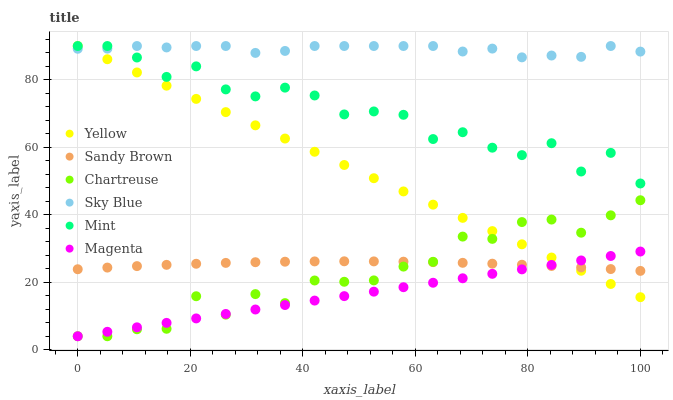Does Magenta have the minimum area under the curve?
Answer yes or no. Yes. Does Sky Blue have the maximum area under the curve?
Answer yes or no. Yes. Does Yellow have the minimum area under the curve?
Answer yes or no. No. Does Yellow have the maximum area under the curve?
Answer yes or no. No. Is Magenta the smoothest?
Answer yes or no. Yes. Is Mint the roughest?
Answer yes or no. Yes. Is Yellow the smoothest?
Answer yes or no. No. Is Yellow the roughest?
Answer yes or no. No. Does Chartreuse have the lowest value?
Answer yes or no. Yes. Does Yellow have the lowest value?
Answer yes or no. No. Does Sky Blue have the highest value?
Answer yes or no. Yes. Does Chartreuse have the highest value?
Answer yes or no. No. Is Magenta less than Mint?
Answer yes or no. Yes. Is Mint greater than Sandy Brown?
Answer yes or no. Yes. Does Magenta intersect Yellow?
Answer yes or no. Yes. Is Magenta less than Yellow?
Answer yes or no. No. Is Magenta greater than Yellow?
Answer yes or no. No. Does Magenta intersect Mint?
Answer yes or no. No. 